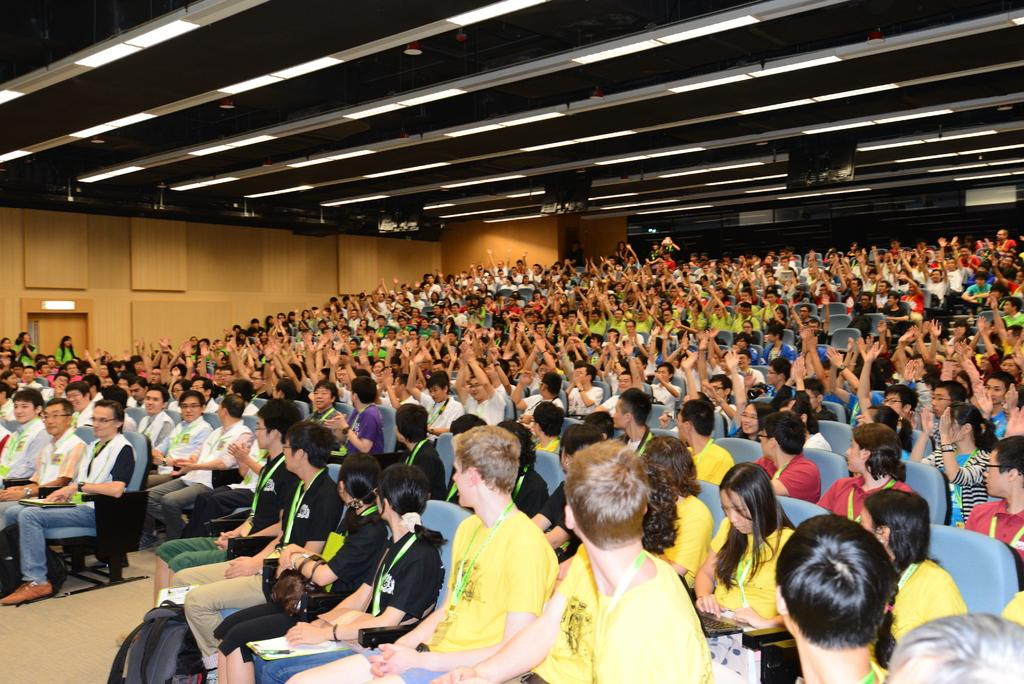Where was the image taken? The image was taken in an auditorium. What can be seen in the auditorium? There are audience members sitting in chairs. What is visible on the ceiling of the auditorium? There are lights on the ceiling. What type of wave can be seen crashing on the shore in the image? There is no wave or shore present in the image; it was taken in an auditorium. 